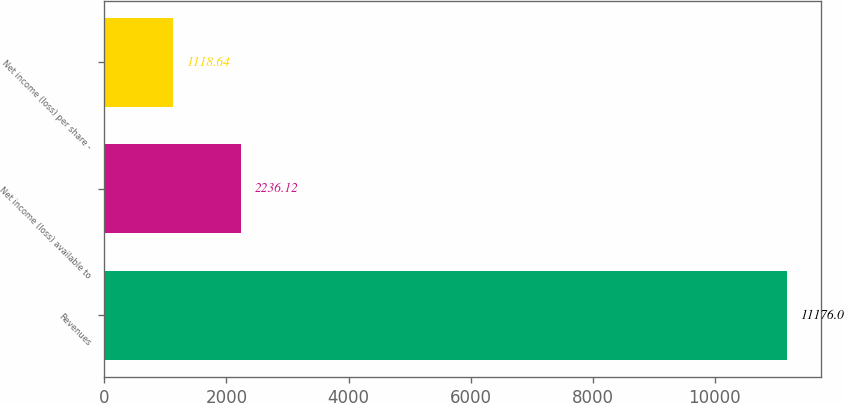Convert chart to OTSL. <chart><loc_0><loc_0><loc_500><loc_500><bar_chart><fcel>Revenues<fcel>Net income (loss) available to<fcel>Net income (loss) per share -<nl><fcel>11176<fcel>2236.12<fcel>1118.64<nl></chart> 